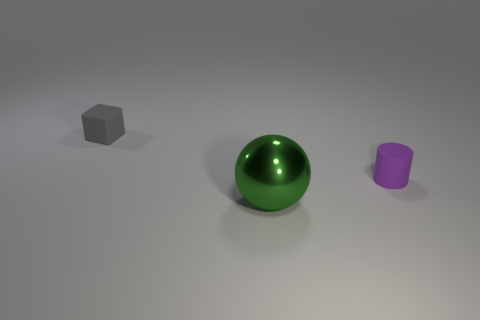The thing that is made of the same material as the small purple cylinder is what color?
Ensure brevity in your answer.  Gray. How many small objects are either purple cylinders or gray cubes?
Give a very brief answer. 2. There is a purple matte object; what number of purple cylinders are to the left of it?
Your answer should be very brief. 0. How many metallic objects are either gray cubes or large green things?
Your response must be concise. 1. There is a tiny thing in front of the small matte thing left of the small cylinder; is there a purple rubber cylinder in front of it?
Keep it short and to the point. No. The big metallic sphere is what color?
Give a very brief answer. Green. Is the shape of the matte thing that is left of the purple cylinder the same as  the large green object?
Make the answer very short. No. How many objects are either cyan rubber cylinders or small rubber objects right of the green metal thing?
Provide a short and direct response. 1. Does the tiny thing that is in front of the small rubber cube have the same material as the gray thing?
Offer a very short reply. Yes. Is there anything else that has the same size as the purple matte thing?
Your answer should be compact. Yes. 